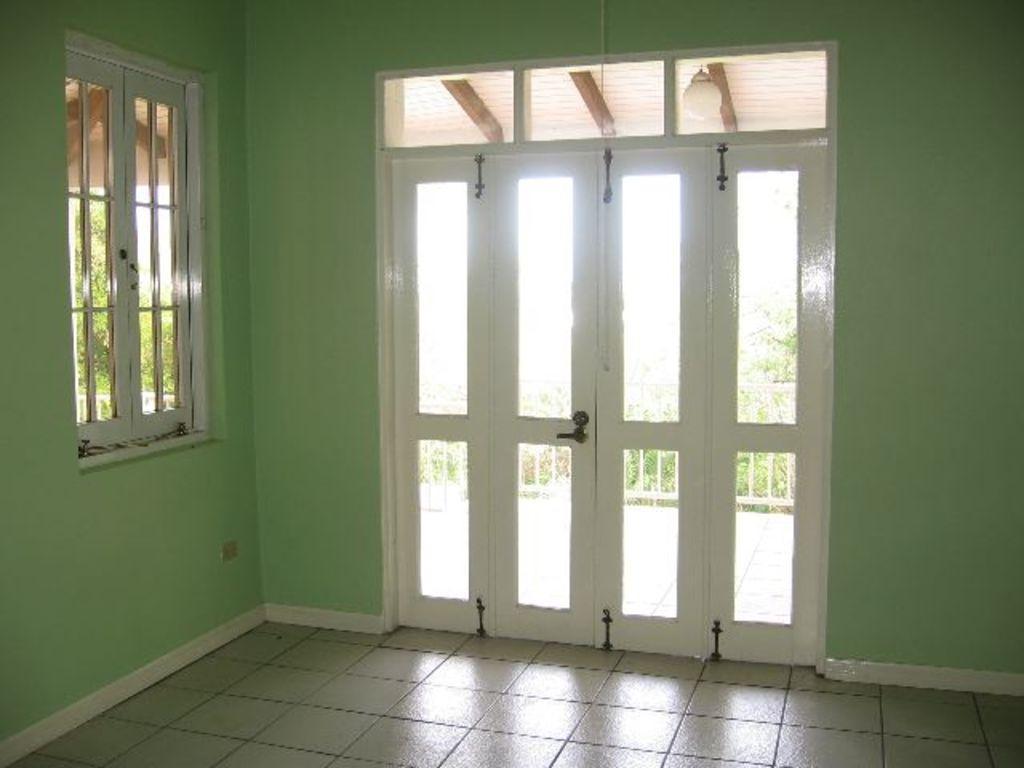Could you give a brief overview of what you see in this image? Here in this picture we can see the inner view of a room, as we can see the windows and doors present and through that we can see a railing present and we can see plants and trees present outside and we can also see a light hanging on the shed. 